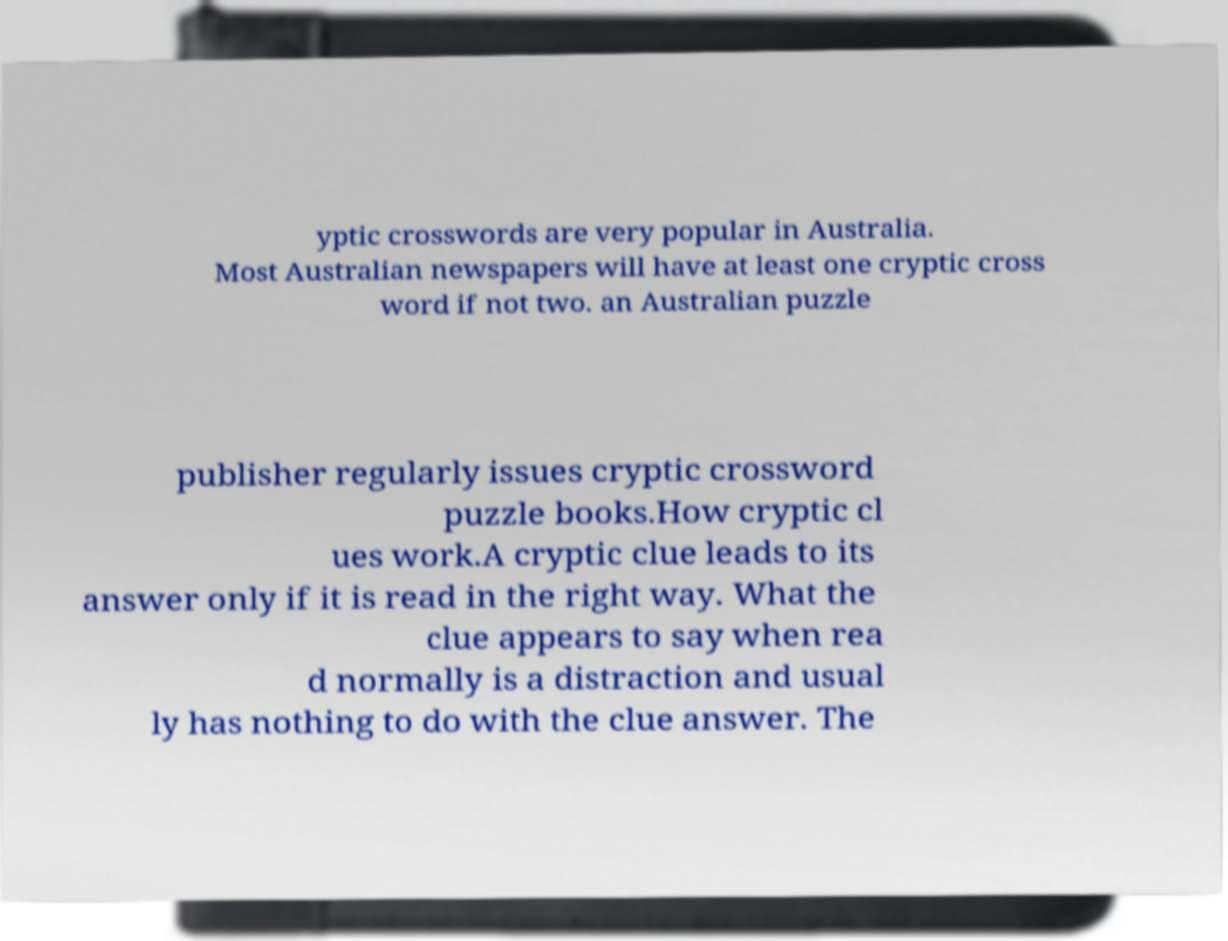I need the written content from this picture converted into text. Can you do that? yptic crosswords are very popular in Australia. Most Australian newspapers will have at least one cryptic cross word if not two. an Australian puzzle publisher regularly issues cryptic crossword puzzle books.How cryptic cl ues work.A cryptic clue leads to its answer only if it is read in the right way. What the clue appears to say when rea d normally is a distraction and usual ly has nothing to do with the clue answer. The 